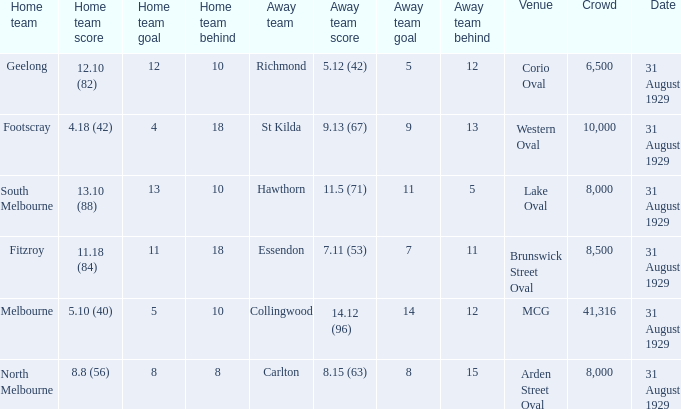What date was the game when the away team was carlton? 31 August 1929. 